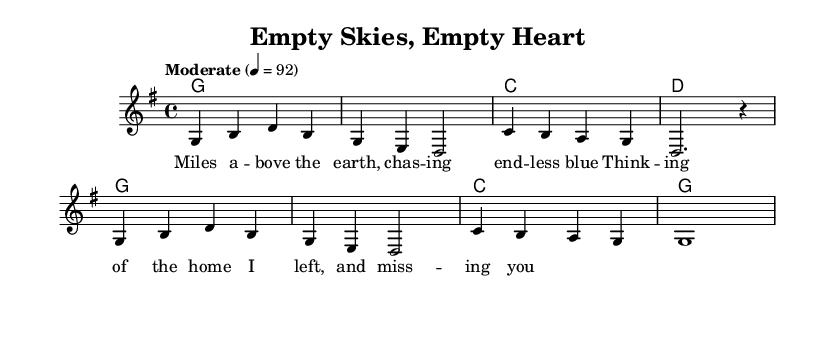What is the key signature of this music? The key signature indicates that the piece is in G major, which has one sharp (F#). This can be confirmed by looking at the key signature indicated at the beginning of the score.
Answer: G major What is the time signature of this music? The time signature is found at the beginning of the score, expressed as 4/4. This means there are four beats in each measure and the quarter note gets one beat.
Answer: 4/4 What is the tempo marking given in the score? The tempo marking is specified in the score as "Moderate" with a metronome indication of 4 = 92, meaning the quarter note should be played at a speed of 92 beats per minute.
Answer: Moderate 4 = 92 How many measures are there in the melody? By counting the measures in the melody line, we find that there are a total of 8 measures, as indicated by the groupings between the vertical lines separating each measure.
Answer: 8 measures What is the first lyric line of the song? The lyrics are aligned with the melody, and the first set of words corresponds to the first measure of melody. Reading that line, we find it reads "Miles a -- bove the earth, chas -- ing end -- less blue."
Answer: Miles a -- bove the earth, chas -- ing end -- less blue What chord follows the second measure of the melody? The chord progression indicates that after the second measure of the melody (which corresponds to "chasing endless blue"), the harmony shows that a C chord is played following the G chord of the first measure.
Answer: C What theme is reflected in the lyrics of this song? The lyrics express feelings associated with being away from home, highlighting themes of loneliness and longing. This theme resonates in the line about missing home while being above the earth.
Answer: Loneliness and longing 